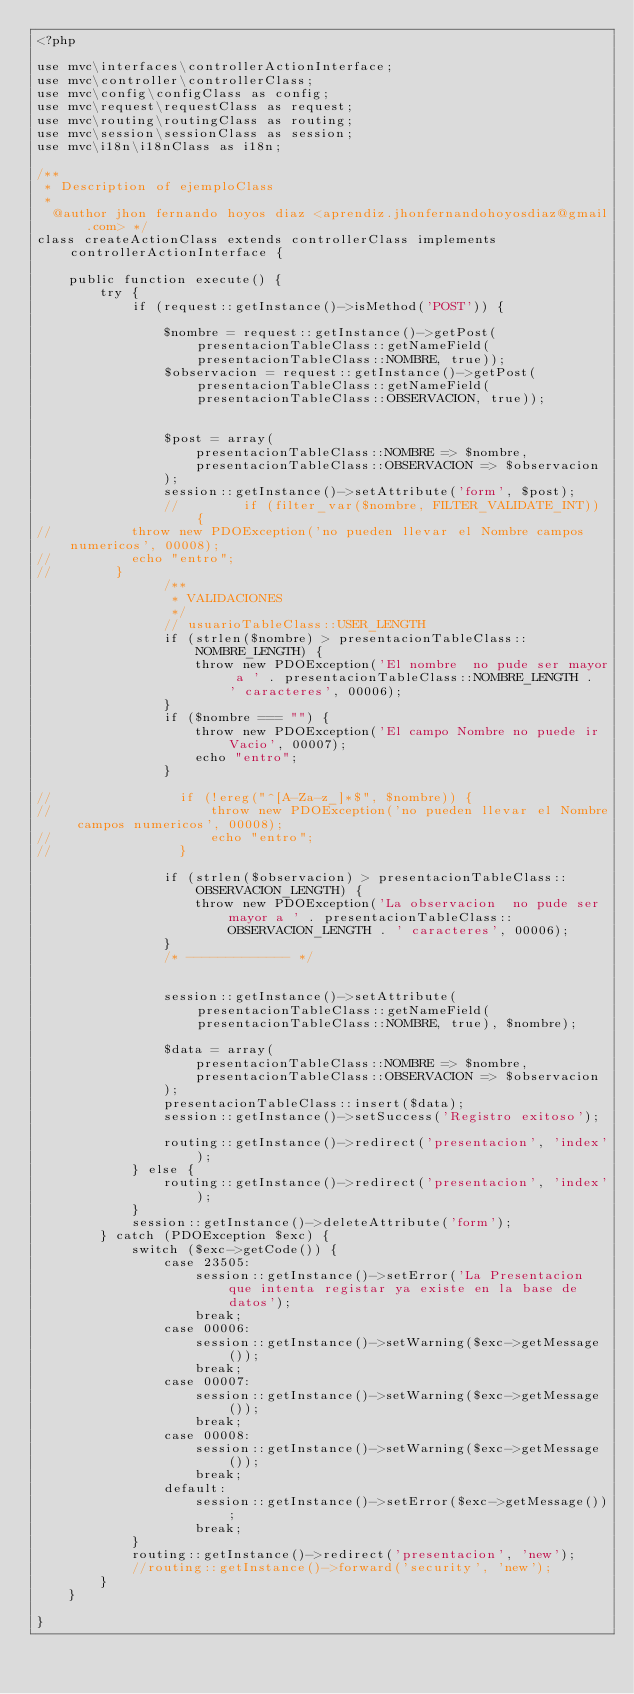<code> <loc_0><loc_0><loc_500><loc_500><_PHP_><?php

use mvc\interfaces\controllerActionInterface;
use mvc\controller\controllerClass;
use mvc\config\configClass as config;
use mvc\request\requestClass as request;
use mvc\routing\routingClass as routing;
use mvc\session\sessionClass as session;
use mvc\i18n\i18nClass as i18n;

/**
 * Description of ejemploClass
 *
  @author jhon fernando hoyos diaz <aprendiz.jhonfernandohoyosdiaz@gmail.com> */
class createActionClass extends controllerClass implements controllerActionInterface {

    public function execute() {
        try {
            if (request::getInstance()->isMethod('POST')) {

                $nombre = request::getInstance()->getPost(presentacionTableClass::getNameField(presentacionTableClass::NOMBRE, true));
                $observacion = request::getInstance()->getPost(presentacionTableClass::getNameField(presentacionTableClass::OBSERVACION, true));


                $post = array(
                    presentacionTableClass::NOMBRE => $nombre,
                    presentacionTableClass::OBSERVACION => $observacion
                );
                session::getInstance()->setAttribute('form', $post);
                //        if (filter_var($nombre, FILTER_VALIDATE_INT)) {
//          throw new PDOException('no pueden llevar el Nombre campos numericos', 00008);
//          echo "entro";
//        }
                /**
                 * VALIDACIONES
                 */
                // usuarioTableClass::USER_LENGTH
                if (strlen($nombre) > presentacionTableClass::NOMBRE_LENGTH) {
                    throw new PDOException('El nombre  no pude ser mayor a ' . presentacionTableClass::NOMBRE_LENGTH . ' caracteres', 00006);
                }
                if ($nombre === "") {
                    throw new PDOException('El campo Nombre no puede ir Vacio', 00007);
                    echo "entro";
                }

//                if (!ereg("^[A-Za-z_]*$", $nombre)) {
//                    throw new PDOException('no pueden llevar el Nombre campos numericos', 00008);
//                    echo "entro";
//                }

                if (strlen($observacion) > presentacionTableClass::OBSERVACION_LENGTH) {
                    throw new PDOException('La observacion  no pude ser mayor a ' . presentacionTableClass::OBSERVACION_LENGTH . ' caracteres', 00006);
                }
                /* ------------- */


                session::getInstance()->setAttribute(presentacionTableClass::getNameField(presentacionTableClass::NOMBRE, true), $nombre);

                $data = array(
                    presentacionTableClass::NOMBRE => $nombre,
                    presentacionTableClass::OBSERVACION => $observacion
                );
                presentacionTableClass::insert($data);
                session::getInstance()->setSuccess('Registro exitoso');

                routing::getInstance()->redirect('presentacion', 'index');
            } else {
                routing::getInstance()->redirect('presentacion', 'index');
            }
            session::getInstance()->deleteAttribute('form');
        } catch (PDOException $exc) {
            switch ($exc->getCode()) {
                case 23505:
                    session::getInstance()->setError('La Presentacion que intenta registar ya existe en la base de datos');
                    break;
                case 00006:
                    session::getInstance()->setWarning($exc->getMessage());
                    break;
                case 00007:
                    session::getInstance()->setWarning($exc->getMessage());
                    break;
                case 00008:
                    session::getInstance()->setWarning($exc->getMessage());
                    break;
                default:
                    session::getInstance()->setError($exc->getMessage());
                    break;
            }
            routing::getInstance()->redirect('presentacion', 'new');
            //routing::getInstance()->forward('security', 'new');
        }
    }

}
</code> 